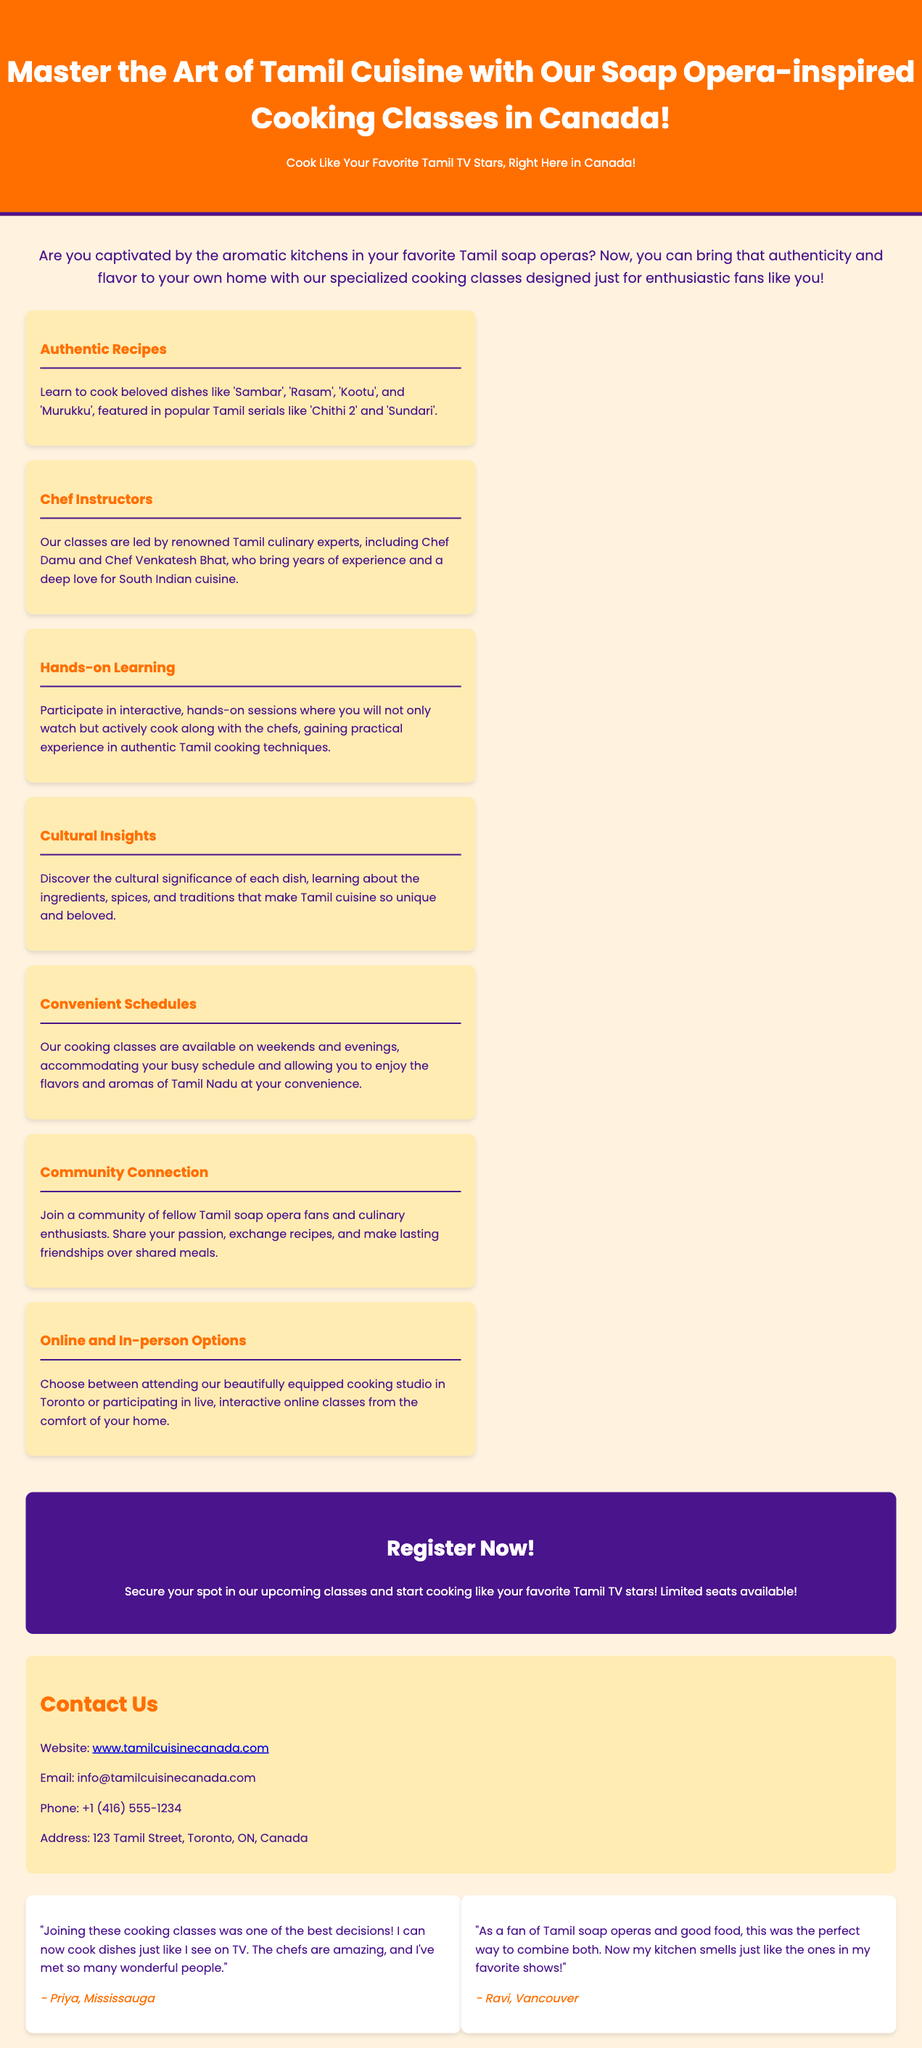What is the title of the cooking classes? The title of the cooking classes is prominently displayed at the top of the document.
Answer: Master the Art of Tamil Cuisine with Our Soap Opera-inspired Cooking Classes in Canada! Who are the renowned chef instructors? The document mentions specific chef instructors with significant experience in Tamil culinary arts.
Answer: Chef Damu and Chef Venkatesh Bhat What is one of the beloved dishes participants will learn to cook? The document lists specific dishes that are part of the cooking classes.
Answer: Sambar What type of learning experience is offered in the classes? The document emphasizes the nature of the learning experience in the cooking classes.
Answer: Hands-on Learning What are the available options for attending the cooking classes? The document clarifies the formats in which the classes can be attended.
Answer: Online and In-person Options How can participants secure their spot in the classes? The document includes a call to action regarding registration for the classes.
Answer: Register Now! What is the contact phone number provided? The document includes specific contact information, including a phone number.
Answer: +1 (416) 555-1234 What is the address of the cooking classes venue? The document specifies the location where the cooking classes are conducted.
Answer: 123 Tamil Street, Toronto, ON, Canada Who shared a testimonial about the cooking classes? The document features testimonials from individuals who attended the classes.
Answer: Priya and Ravi 